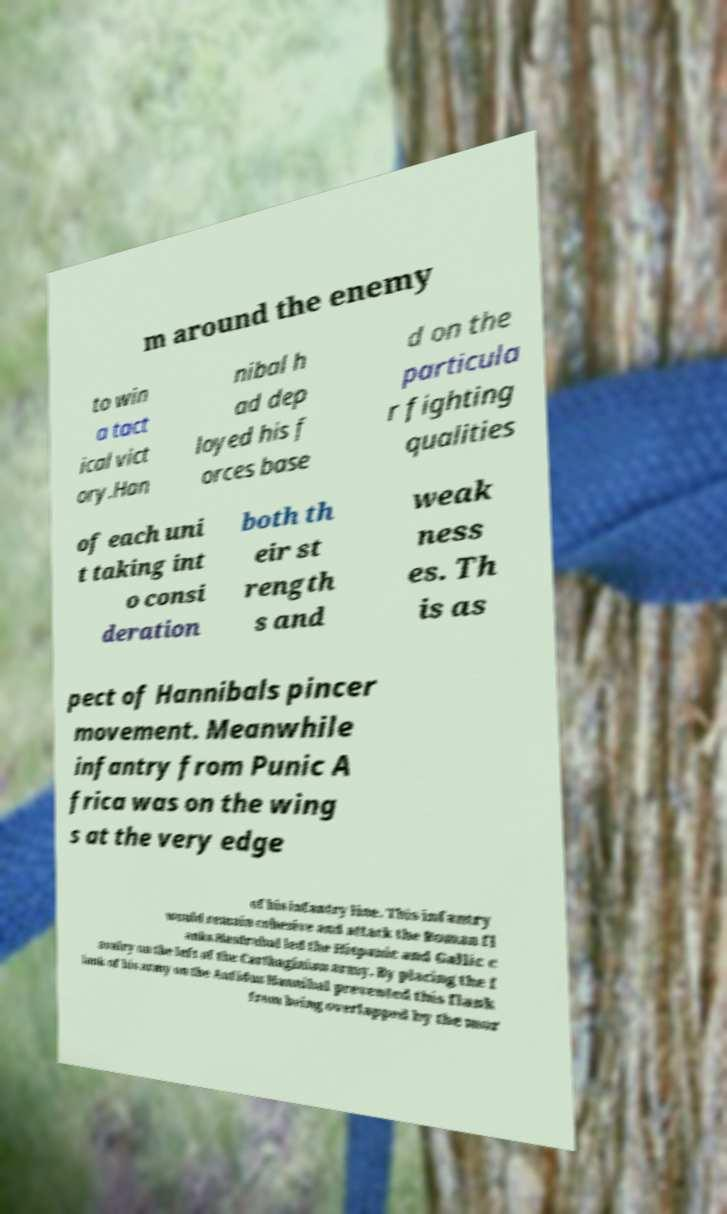Can you accurately transcribe the text from the provided image for me? m around the enemy to win a tact ical vict ory.Han nibal h ad dep loyed his f orces base d on the particula r fighting qualities of each uni t taking int o consi deration both th eir st rength s and weak ness es. Th is as pect of Hannibals pincer movement. Meanwhile infantry from Punic A frica was on the wing s at the very edge of his infantry line. This infantry would remain cohesive and attack the Roman fl anks.Hasdrubal led the Hispanic and Gallic c avalry on the left of the Carthaginian army. By placing the f lank of his army on the Aufidus Hannibal prevented this flank from being overlapped by the mor 